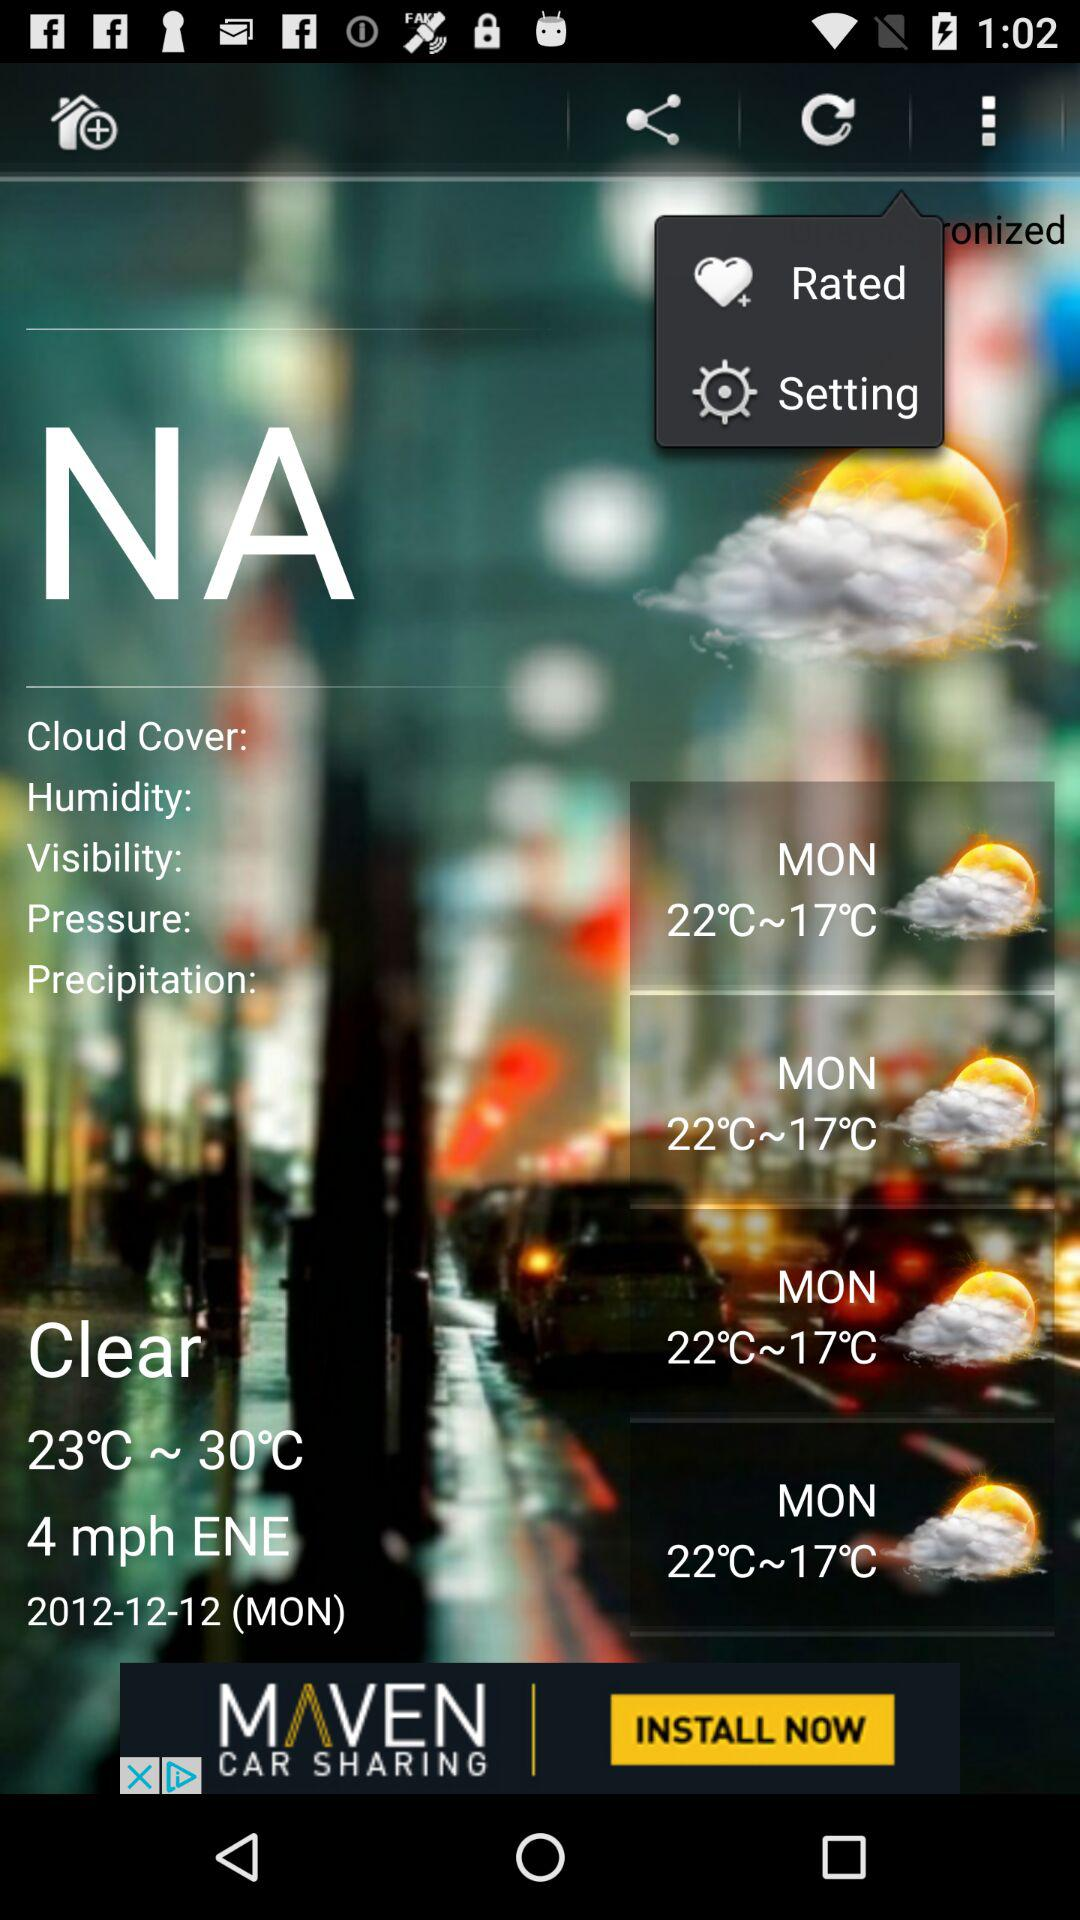What is the date? The date is Monday, December 12, 2012. 